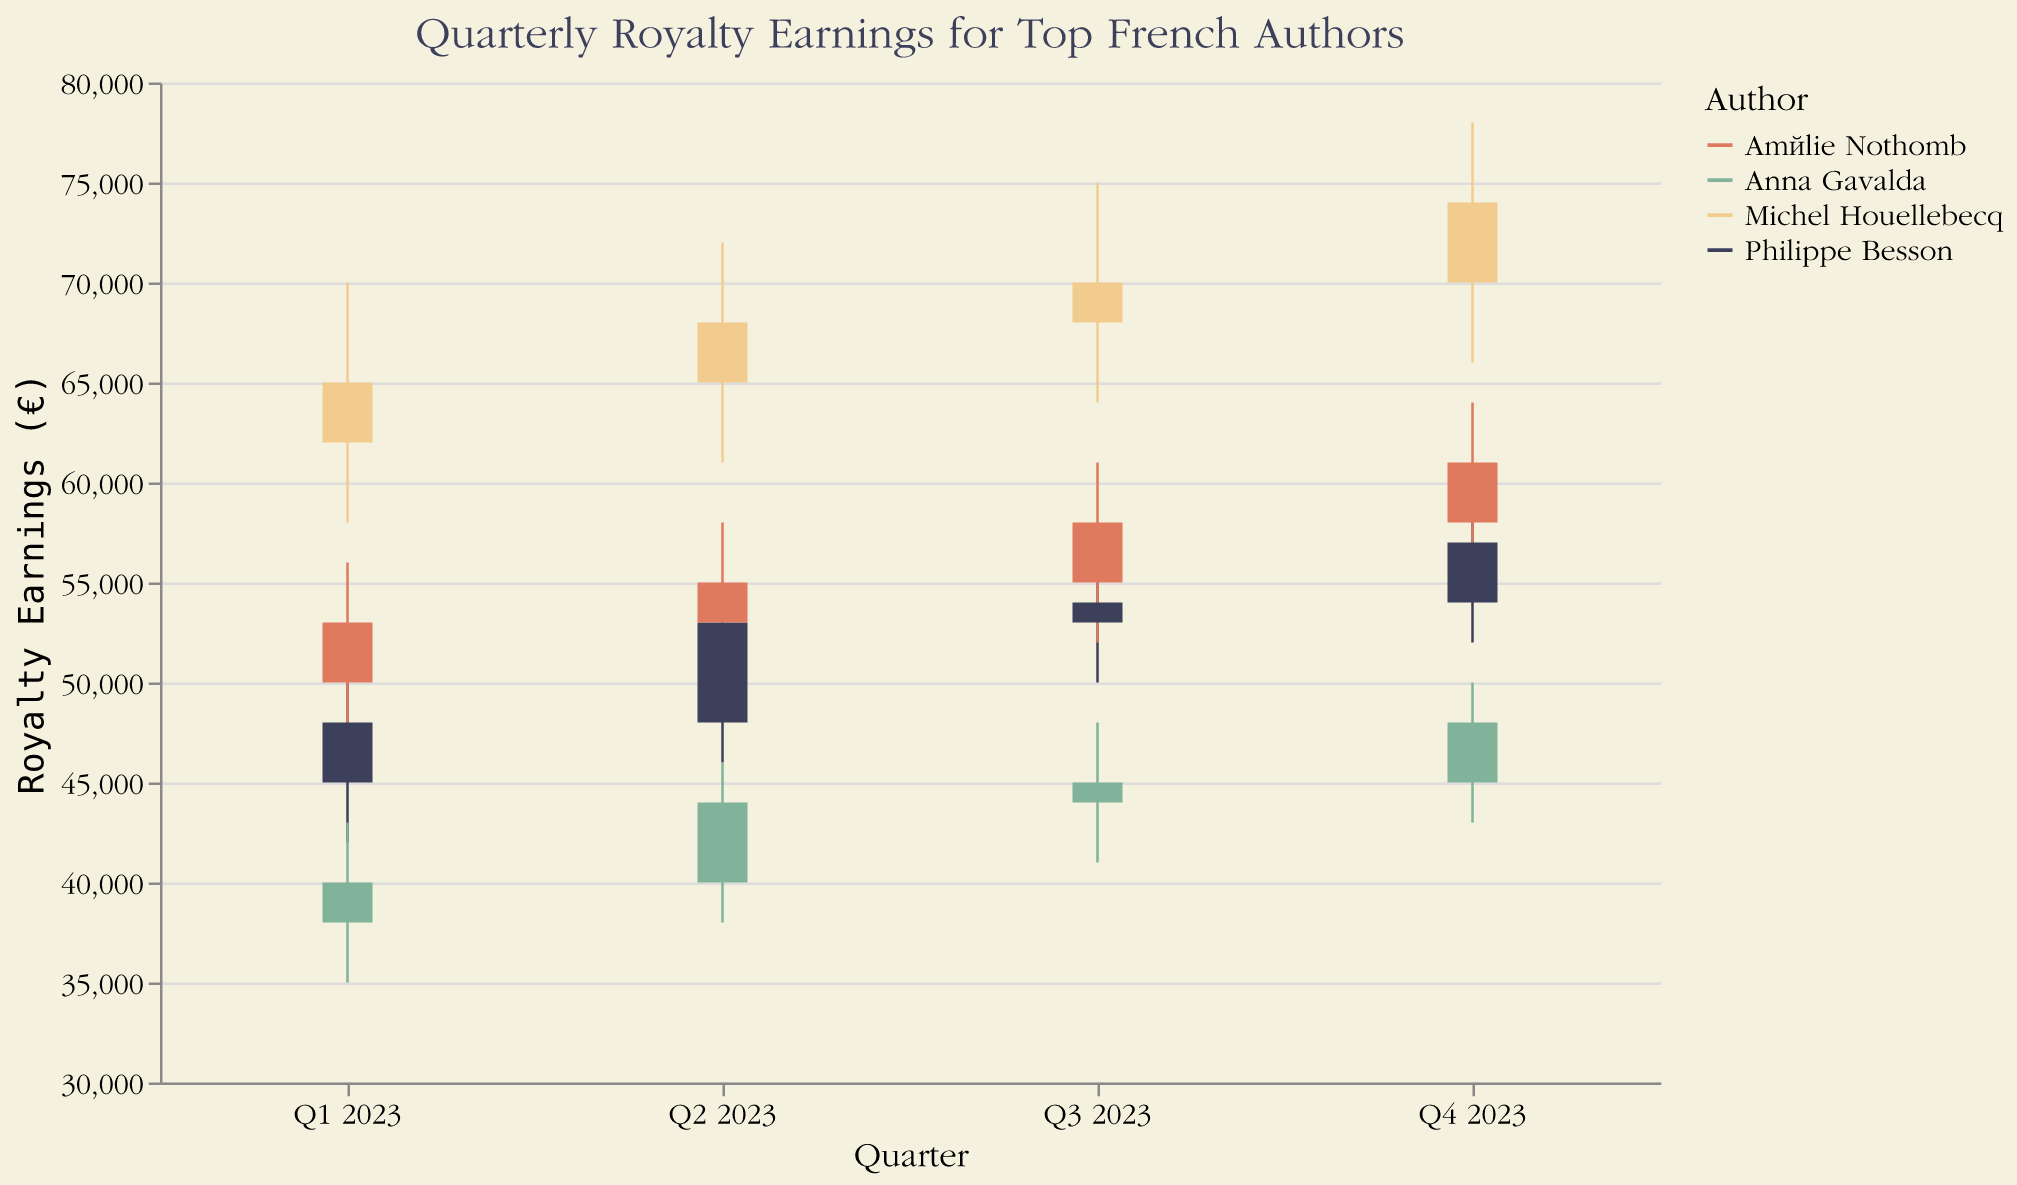How can I identify which author's royalty earnings peaked the highest in Q2 2023? Look at the "High" values for Q2 2023 for all authors and identify the highest value. Michel Houellebecq's earnings peaked at €72,000 in Q2 2023, which is the highest among the authors.
Answer: Michel Houellebecq Who had the lowest opening earnings in Q1 2023? Look at the "Open" values for Q1 2023 for all authors and find the lowest value. Anna Gavalda had the lowest opening earnings with €38,000.
Answer: Anna Gavalda What was the approximate average closing earnings for Philippe Besson in 2023? Sum the closing earnings for Philippe Besson for each quarter and divide by the number of quarters. The values are €48,000, €53,000, €54,000, and €57,000. The sum is €212,000, divided by 4, gives an average of €53,000.
Answer: €53,000 Which author had the most consistent quarterly earnings, and how can you tell? Identify the author with the smallest range (difference between the highest and lowest earnings) over the quarters. Anna Gavalda’s earnings range from €35,000 to €50,000, resulting in a range of €15,000. Other authors show larger fluctuations, so Anna Gavalda had the most consistent earnings.
Answer: Anna Gavalda How did Michel Houellebecq’s closing earnings change from Q1 to Q4 2023? Identify Michel Houellebecq’s closing earnings for Q1 and Q4 2023 and calculate the difference. His earnings were €65,000 in Q1 and €74,000 in Q4. The change is an increase of €9,000.
Answer: Increased by €9,000 Whose highest earnings in Q4 2023 were closest to their earnings in Q1 2023? Compare the "High" values of Q4 to Q1 for each author. For Philippe Besson, Q4 is €60,000 and Q1 is €52,000, a difference of €8,000. For Anna Gavalda, Q4 is €50,000 and Q1 is €43,000, a difference of €7,000. For Michel Houellebecq, Q4 is €78,000, Q1 is €70,000, a difference of €8,000. For Amélie Nothomb, Q4 is €64,000 and Q1 is €56,000, a difference of €8,000. Therefore, Anna Gavalda's €50,000 in Q4 is the closest to her Q1 earnings.
Answer: Anna Gavalda What quarter had the highest low earnings for Amélie Nothomb in 2023? Look at the "Low" values for Amélie Nothomb for each quarter and find the highest. The values are €47,000, €50,000, €52,000, and €55,000. The highest is €55,000 in Q4 2023.
Answer: Q4 2023 Which author showed a closing earnings increase in every quarter of 2023? Review the closing earnings for each quarter for every author to see if there's a steady increase. Philippe Besson showed incremental increases: €48,000, €53,000, €54,000, and €57,000, so he had an increase every quarter.
Answer: Philippe Besson 